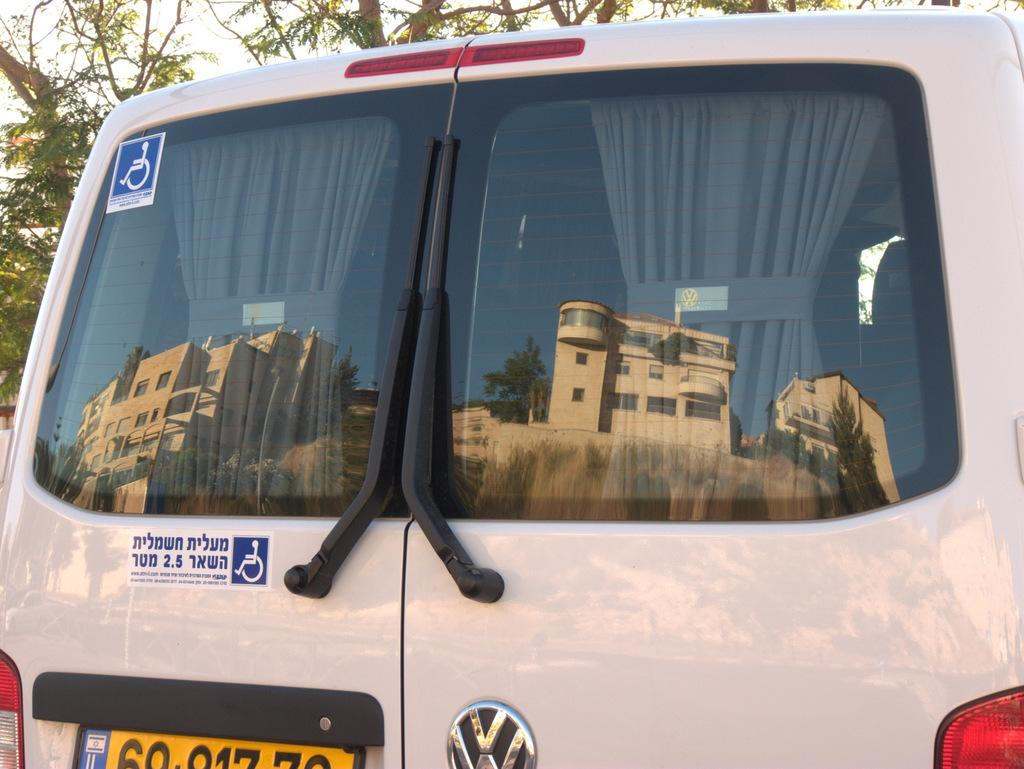What is the color of the vehicle in the image? The vehicle in the image is white. Does the vehicle have any identifying features? Yes, the vehicle has a number plate. What can be seen in the reflection on the vehicle's mirror? There is a reflection of buildings on the mirror of the vehicle. What type of natural scenery is visible in the image? There are trees visible in the image. What part of the natural environment can be seen in the image? The sky is visible in the image. What type of bean is being sold at the business in the image? There is no business or bean present in the image; it features a white vehicle with a number plate and a reflection of buildings on the mirror. 